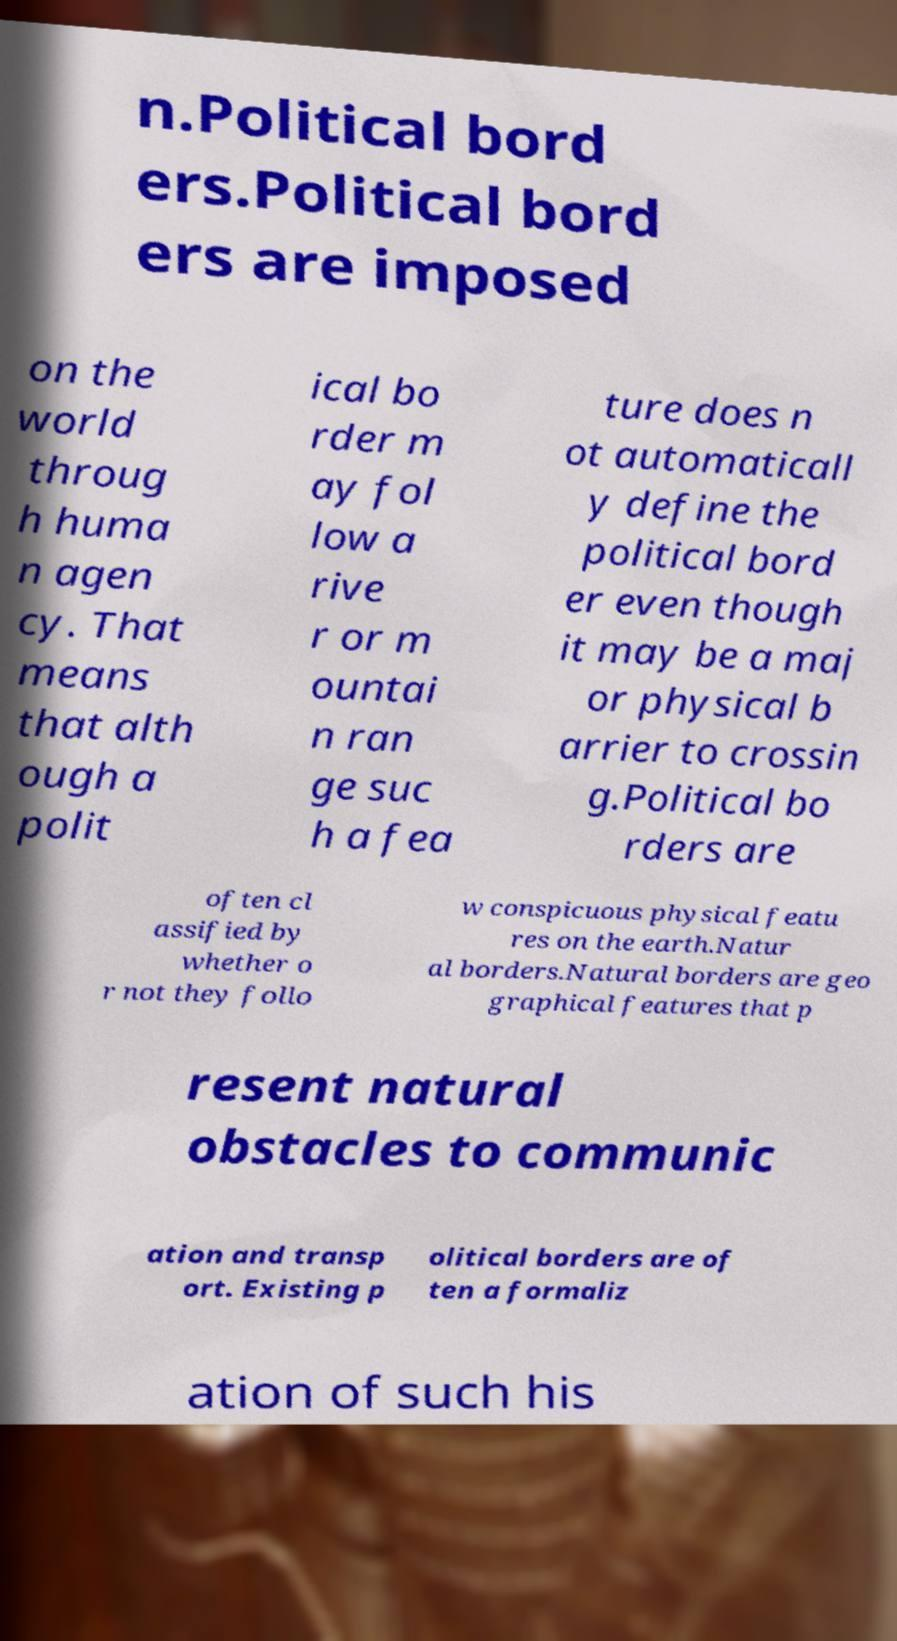Can you read and provide the text displayed in the image?This photo seems to have some interesting text. Can you extract and type it out for me? n.Political bord ers.Political bord ers are imposed on the world throug h huma n agen cy. That means that alth ough a polit ical bo rder m ay fol low a rive r or m ountai n ran ge suc h a fea ture does n ot automaticall y define the political bord er even though it may be a maj or physical b arrier to crossin g.Political bo rders are often cl assified by whether o r not they follo w conspicuous physical featu res on the earth.Natur al borders.Natural borders are geo graphical features that p resent natural obstacles to communic ation and transp ort. Existing p olitical borders are of ten a formaliz ation of such his 